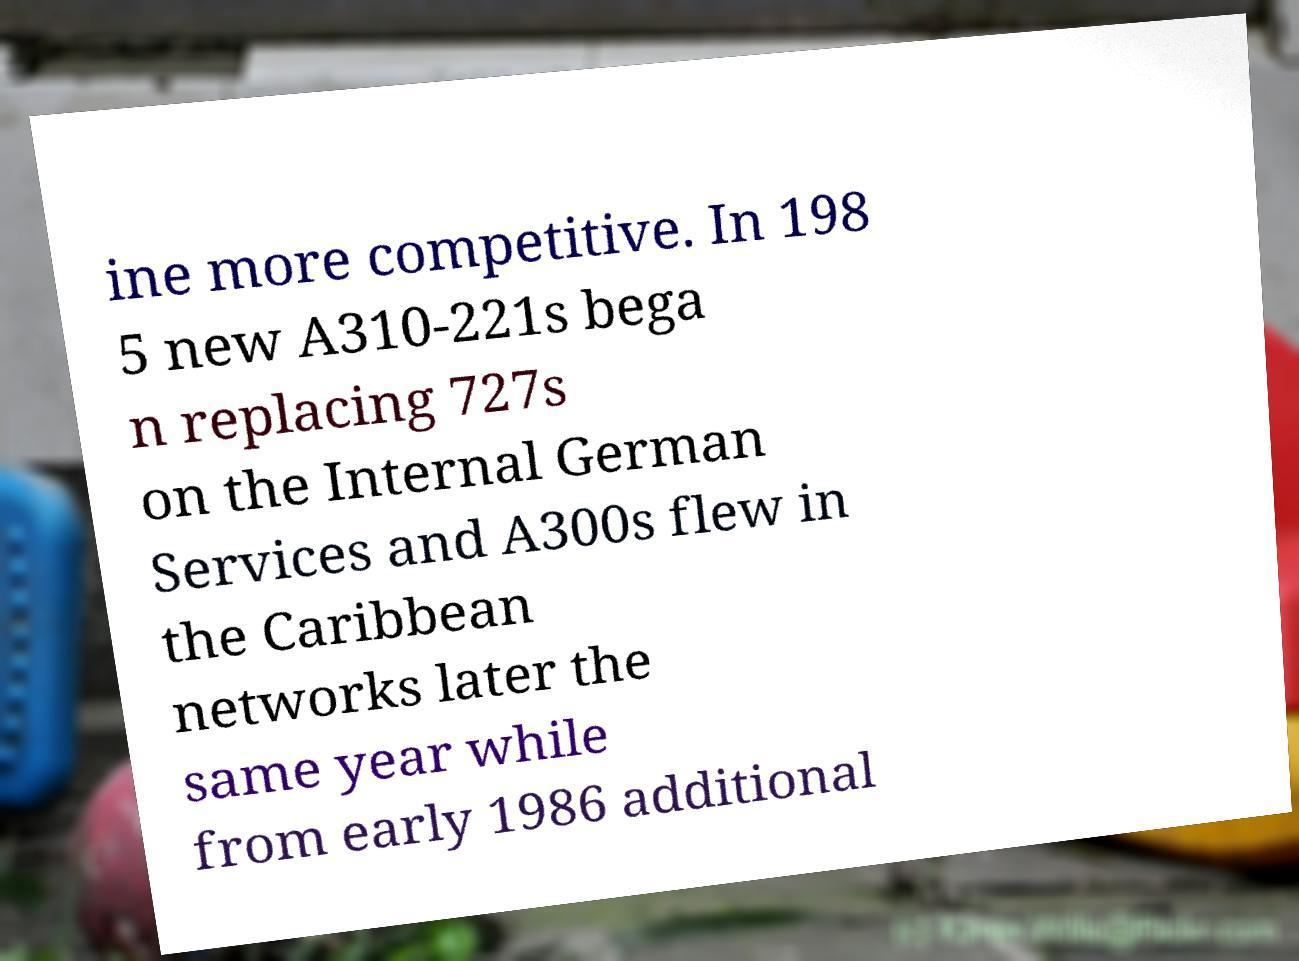What messages or text are displayed in this image? I need them in a readable, typed format. ine more competitive. In 198 5 new A310-221s bega n replacing 727s on the Internal German Services and A300s flew in the Caribbean networks later the same year while from early 1986 additional 